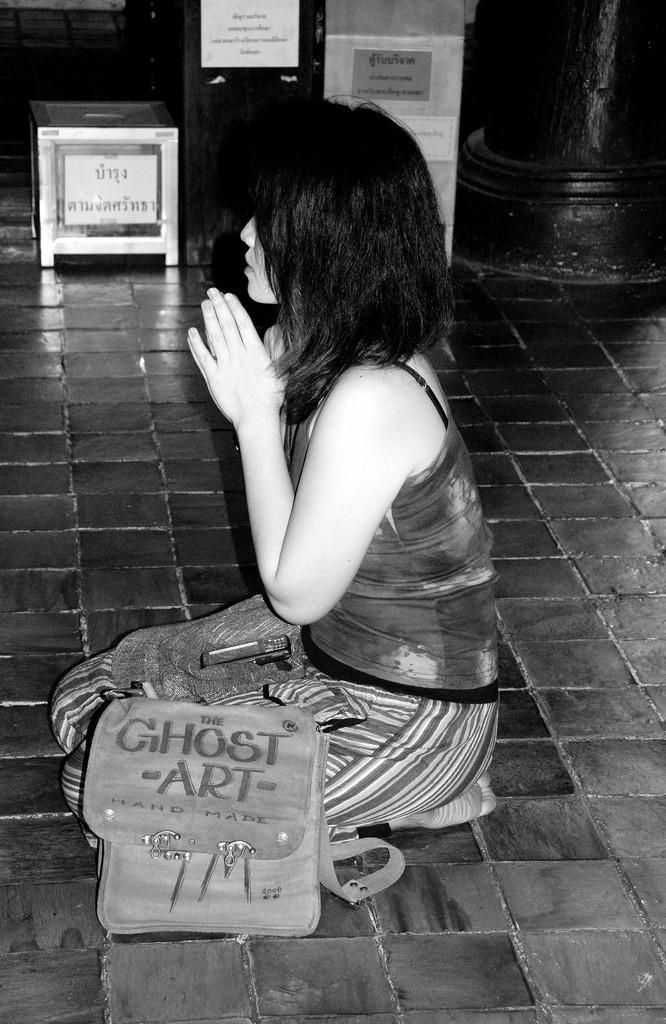Can you describe this image briefly? In this image I can see the person sitting on the floor. To the side I can see the bag. In the back there are some boxes and the stickers attached to that. To the right I can see the pillar and this is a black and white image. 